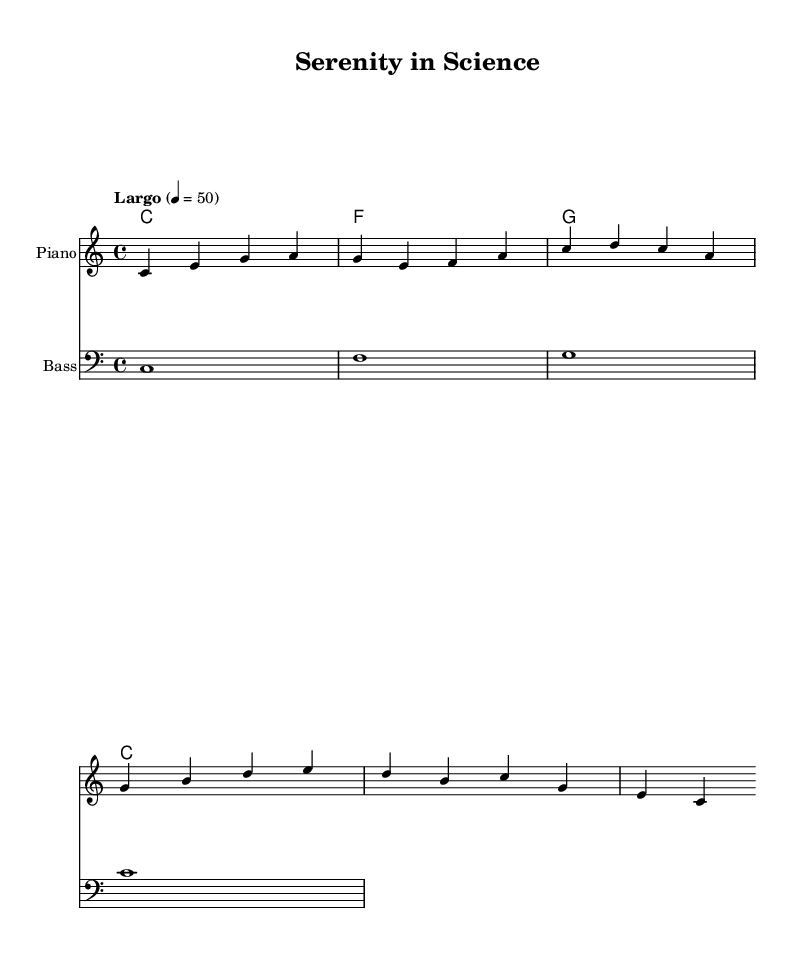What is the key signature of this music? The key signature is C major, which has no sharps or flats, indicated by the absence of any accidentals at the beginning of the staff.
Answer: C major What is the time signature of this music? The time signature is 4/4, which is indicated at the beginning of the staff where the numbers are shown. This indicates that there are four beats in each measure, with a quarter note receiving one beat.
Answer: 4/4 What is the tempo marking for this piece? The tempo marking is "Largo," which indicates a slow tempo, and is noted above the staff at the beginning of the piece. The metronome indication is also provided as 50 beats per minute, further informing the performer of the desired pace.
Answer: Largo How many measures are in the melody section? The melody section consists of four measures, which can be counted from the beginning of the melody line to the end, marked by the bar lines.
Answer: 4 What instruments are specified for this score? The score specifies two instruments: "Piano" for the melody and "Bass" for the bass line, indicated at the beginning of each staff with their respective instrument names.
Answer: Piano and Bass What is the overall mood or theme suggested by the title of the piece? The title "Serenity in Science" suggests a calm and focused atmosphere, indicative of ambient music designed to aid concentration during research and writing. While this isn't derived strictly from the sheet music itself, it can be inferred from the title and the music's characteristics.
Answer: Serenity 